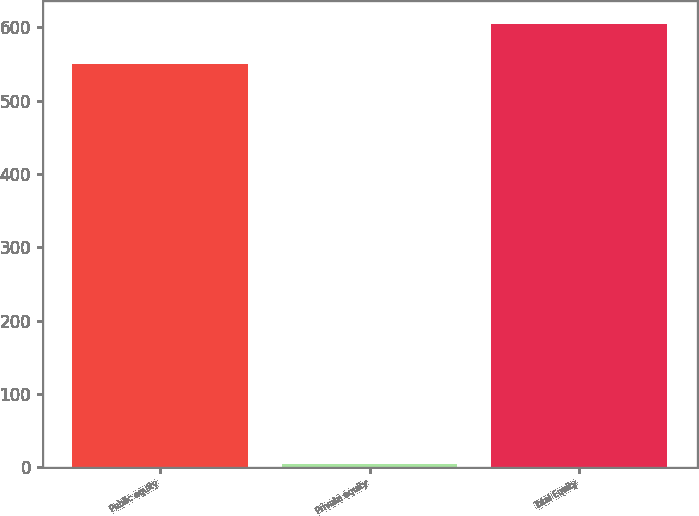Convert chart to OTSL. <chart><loc_0><loc_0><loc_500><loc_500><bar_chart><fcel>Public equity<fcel>Private equity<fcel>Total Equity<nl><fcel>550<fcel>5<fcel>605<nl></chart> 